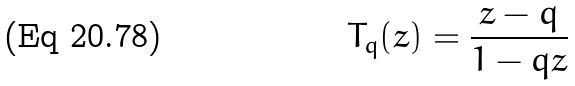<formula> <loc_0><loc_0><loc_500><loc_500>T _ { q } ( z ) = \frac { z - q } { 1 - q z }</formula> 